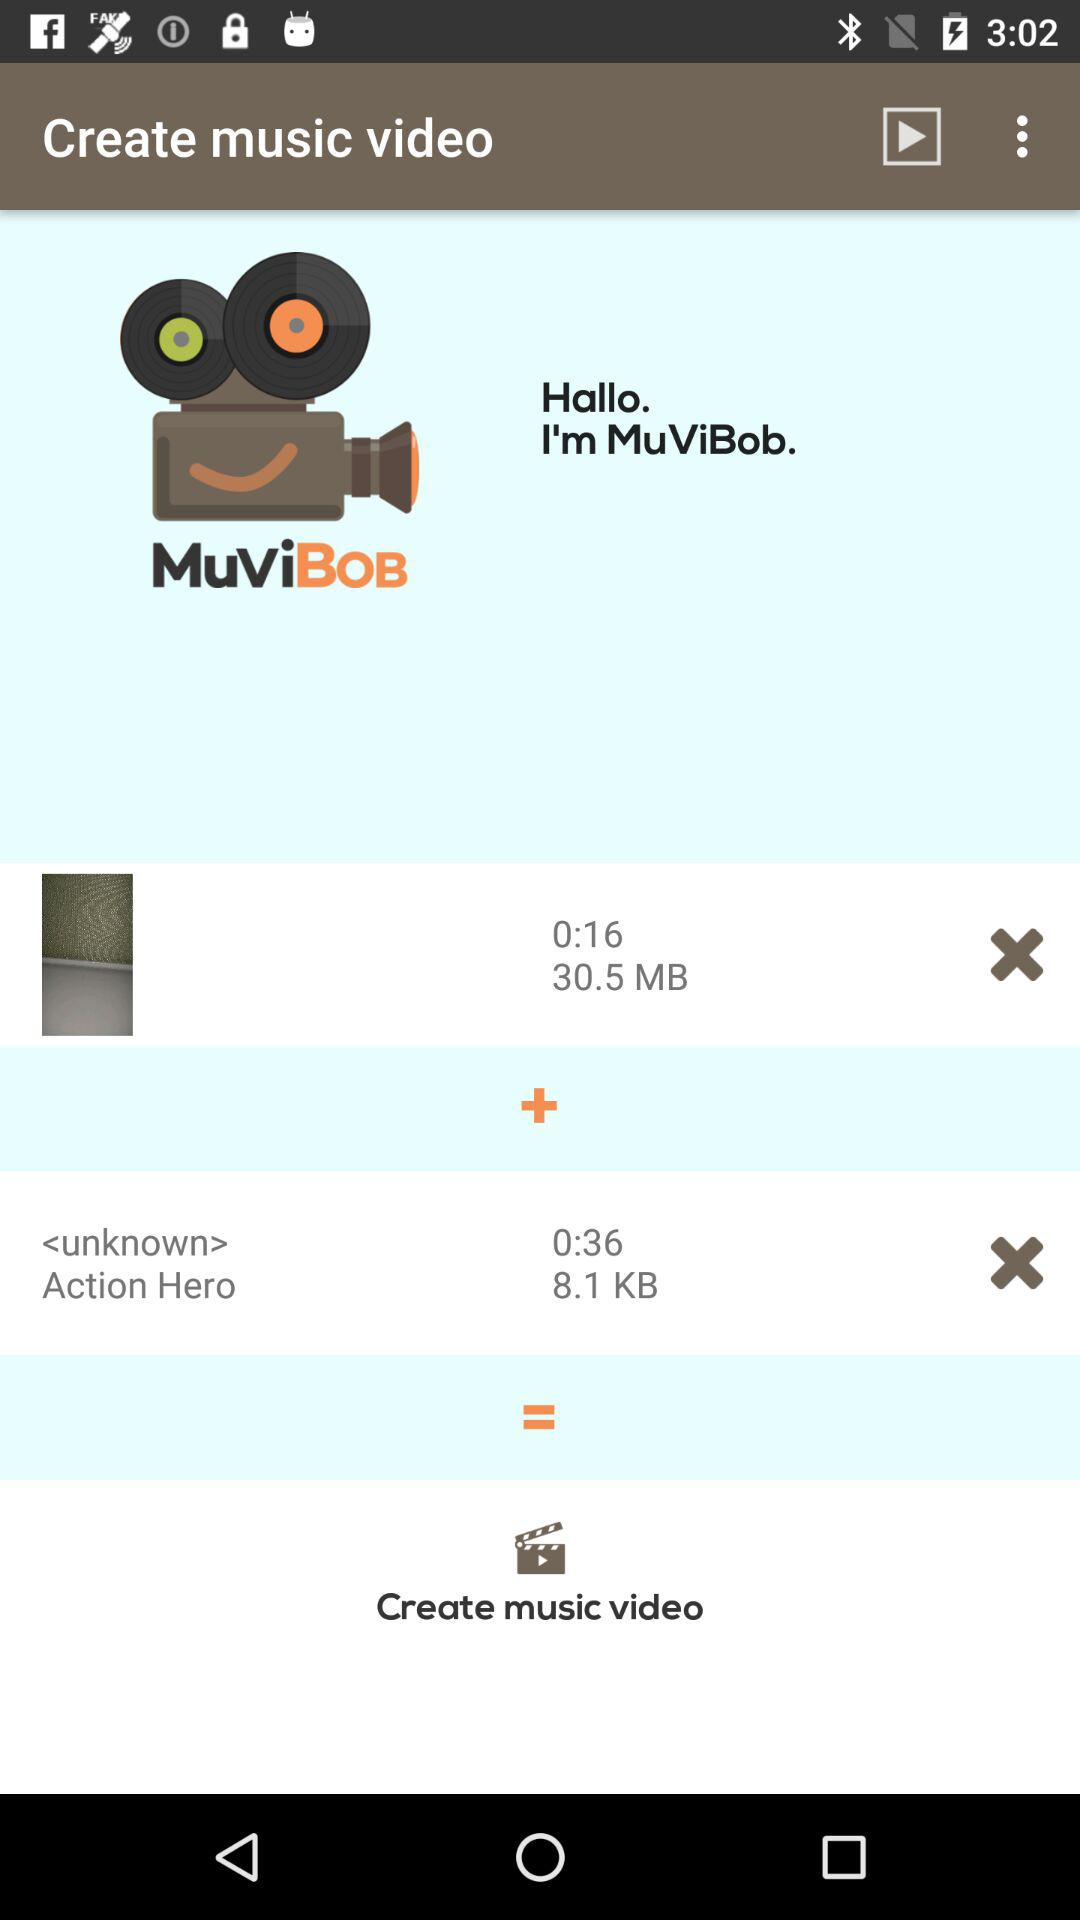How many KB are there in 36 seconds of audio? There are 8.1 KB in 36 seconds of audio. 